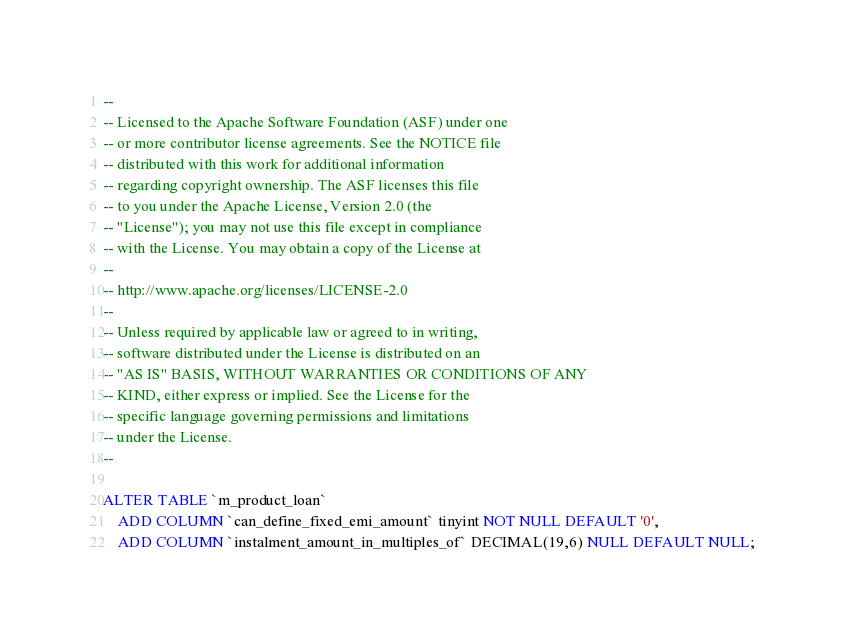Convert code to text. <code><loc_0><loc_0><loc_500><loc_500><_SQL_>--
-- Licensed to the Apache Software Foundation (ASF) under one
-- or more contributor license agreements. See the NOTICE file
-- distributed with this work for additional information
-- regarding copyright ownership. The ASF licenses this file
-- to you under the Apache License, Version 2.0 (the
-- "License"); you may not use this file except in compliance
-- with the License. You may obtain a copy of the License at
--
-- http://www.apache.org/licenses/LICENSE-2.0
--
-- Unless required by applicable law or agreed to in writing,
-- software distributed under the License is distributed on an
-- "AS IS" BASIS, WITHOUT WARRANTIES OR CONDITIONS OF ANY
-- KIND, either express or implied. See the License for the
-- specific language governing permissions and limitations
-- under the License.
--

ALTER TABLE `m_product_loan`
    ADD COLUMN `can_define_fixed_emi_amount` tinyint NOT NULL DEFAULT '0',
    ADD COLUMN `instalment_amount_in_multiples_of` DECIMAL(19,6) NULL DEFAULT NULL;
</code> 